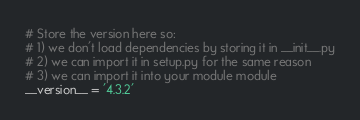Convert code to text. <code><loc_0><loc_0><loc_500><loc_500><_Python_># Store the version here so:
# 1) we don't load dependencies by storing it in __init__.py
# 2) we can import it in setup.py for the same reason
# 3) we can import it into your module module
__version__ = '4.3.2'
</code> 